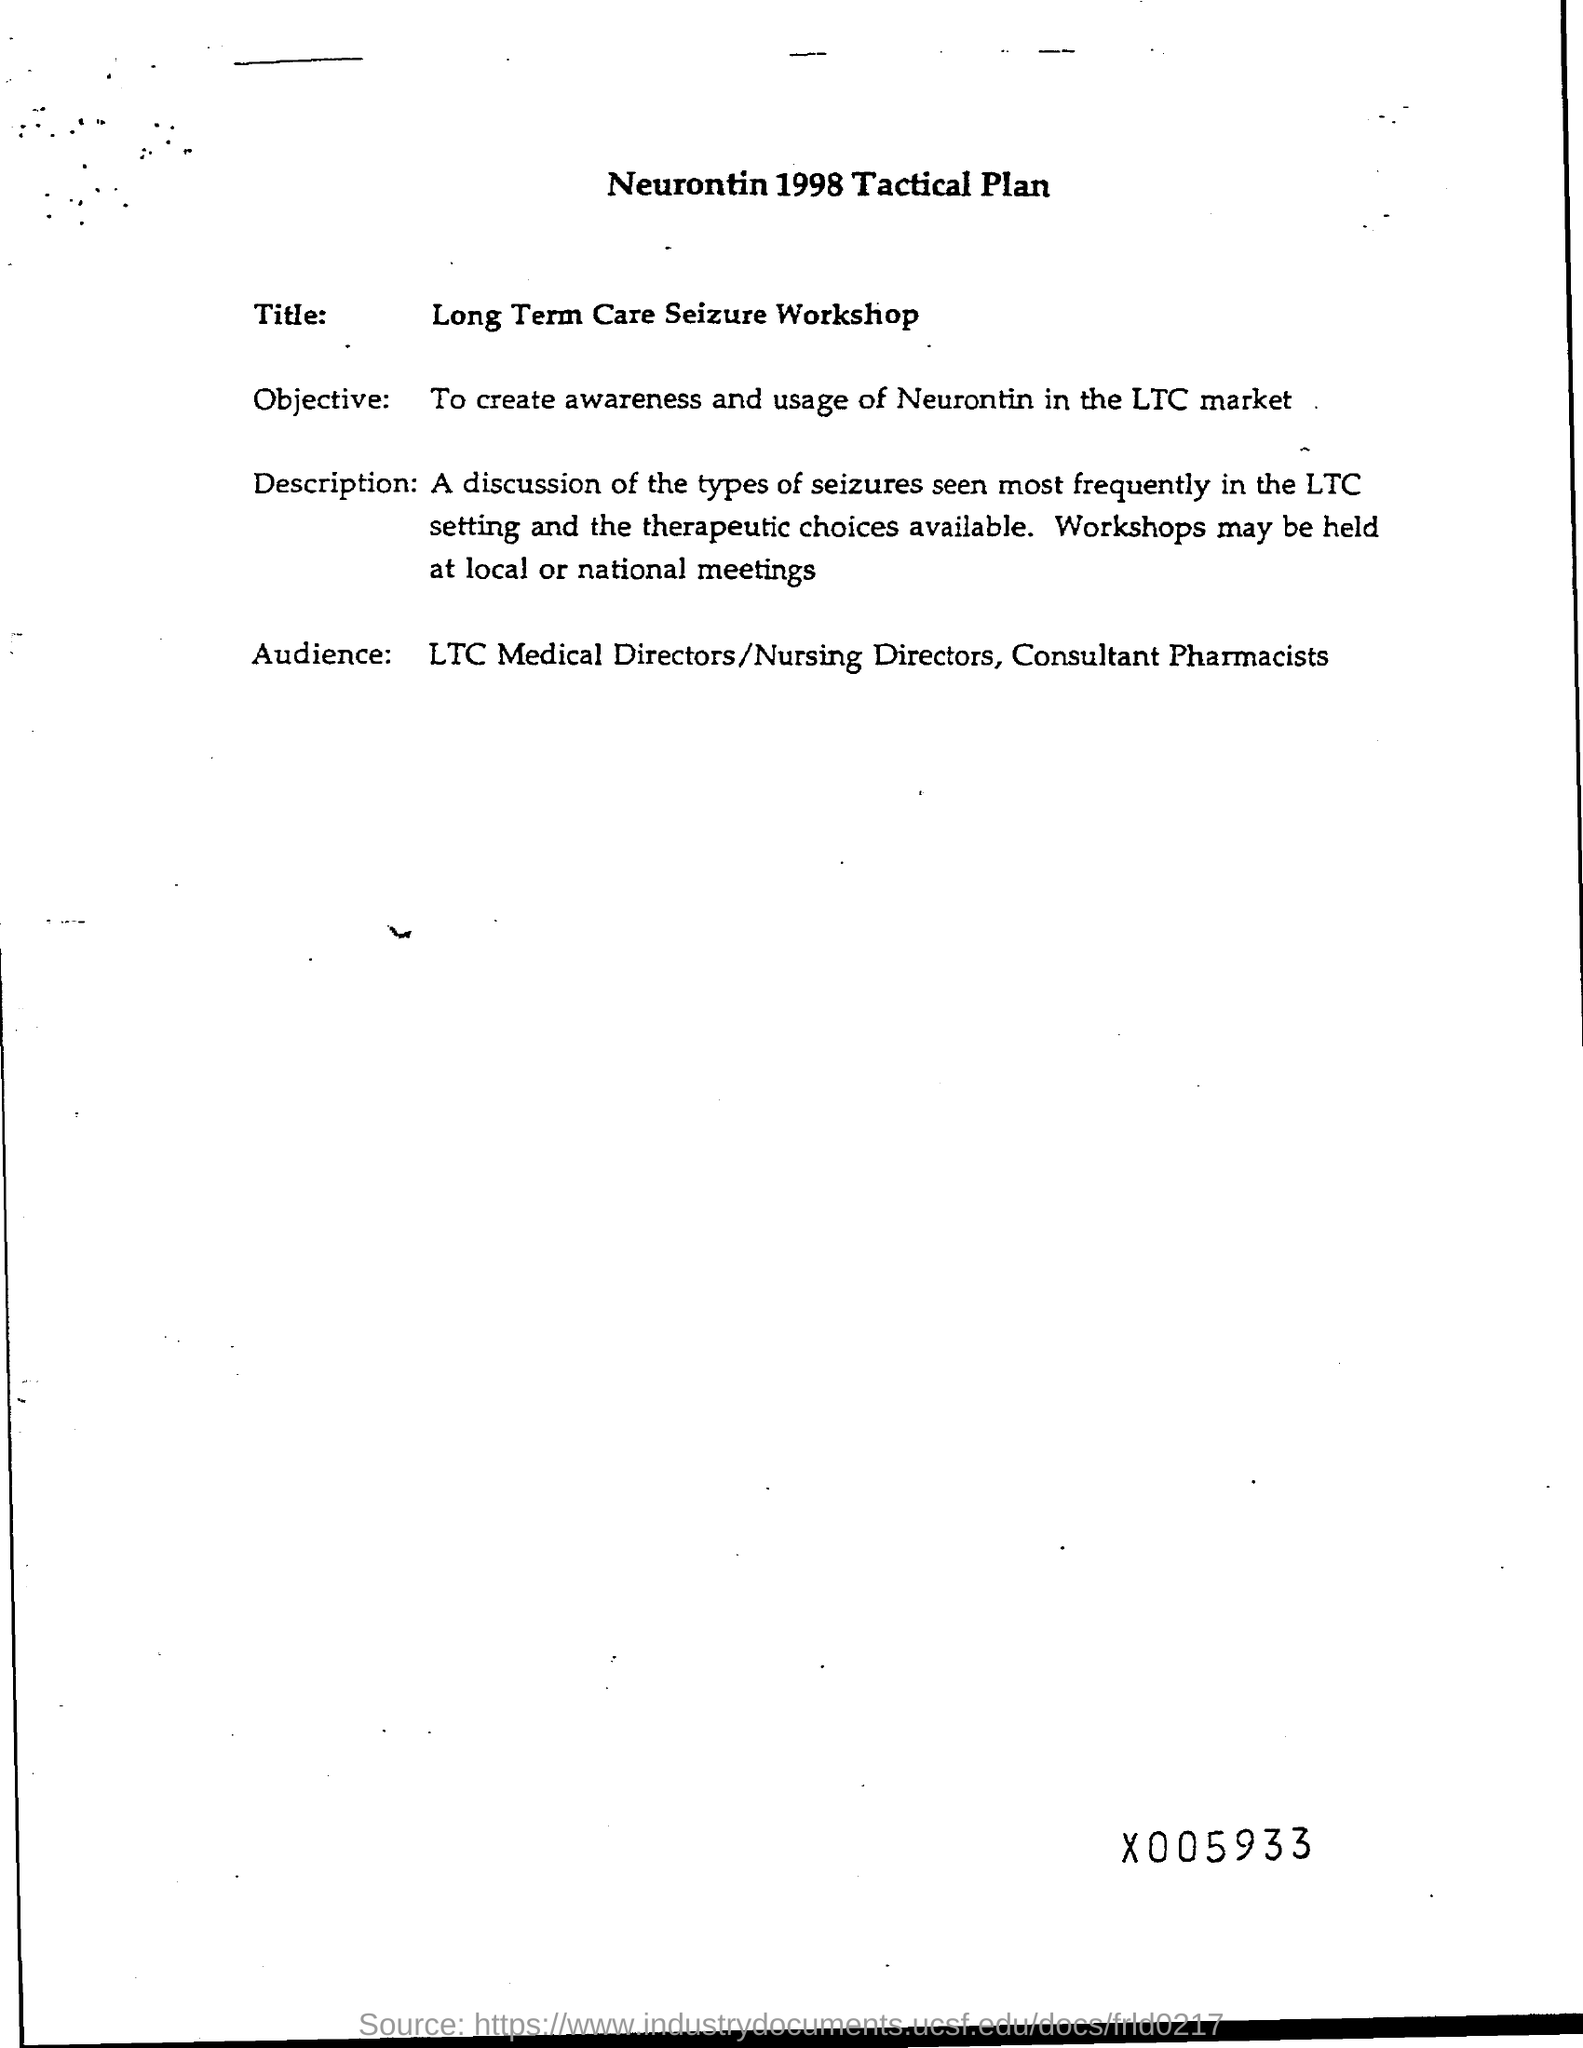Specify some key components in this picture. The goal is to raise awareness and promote the usage of Neurontin in the Long-Term Care (LTC) market. 